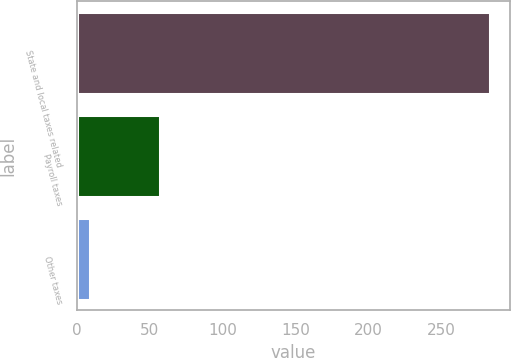Convert chart. <chart><loc_0><loc_0><loc_500><loc_500><bar_chart><fcel>State and local taxes related<fcel>Payroll taxes<fcel>Other taxes<nl><fcel>283<fcel>57<fcel>9<nl></chart> 